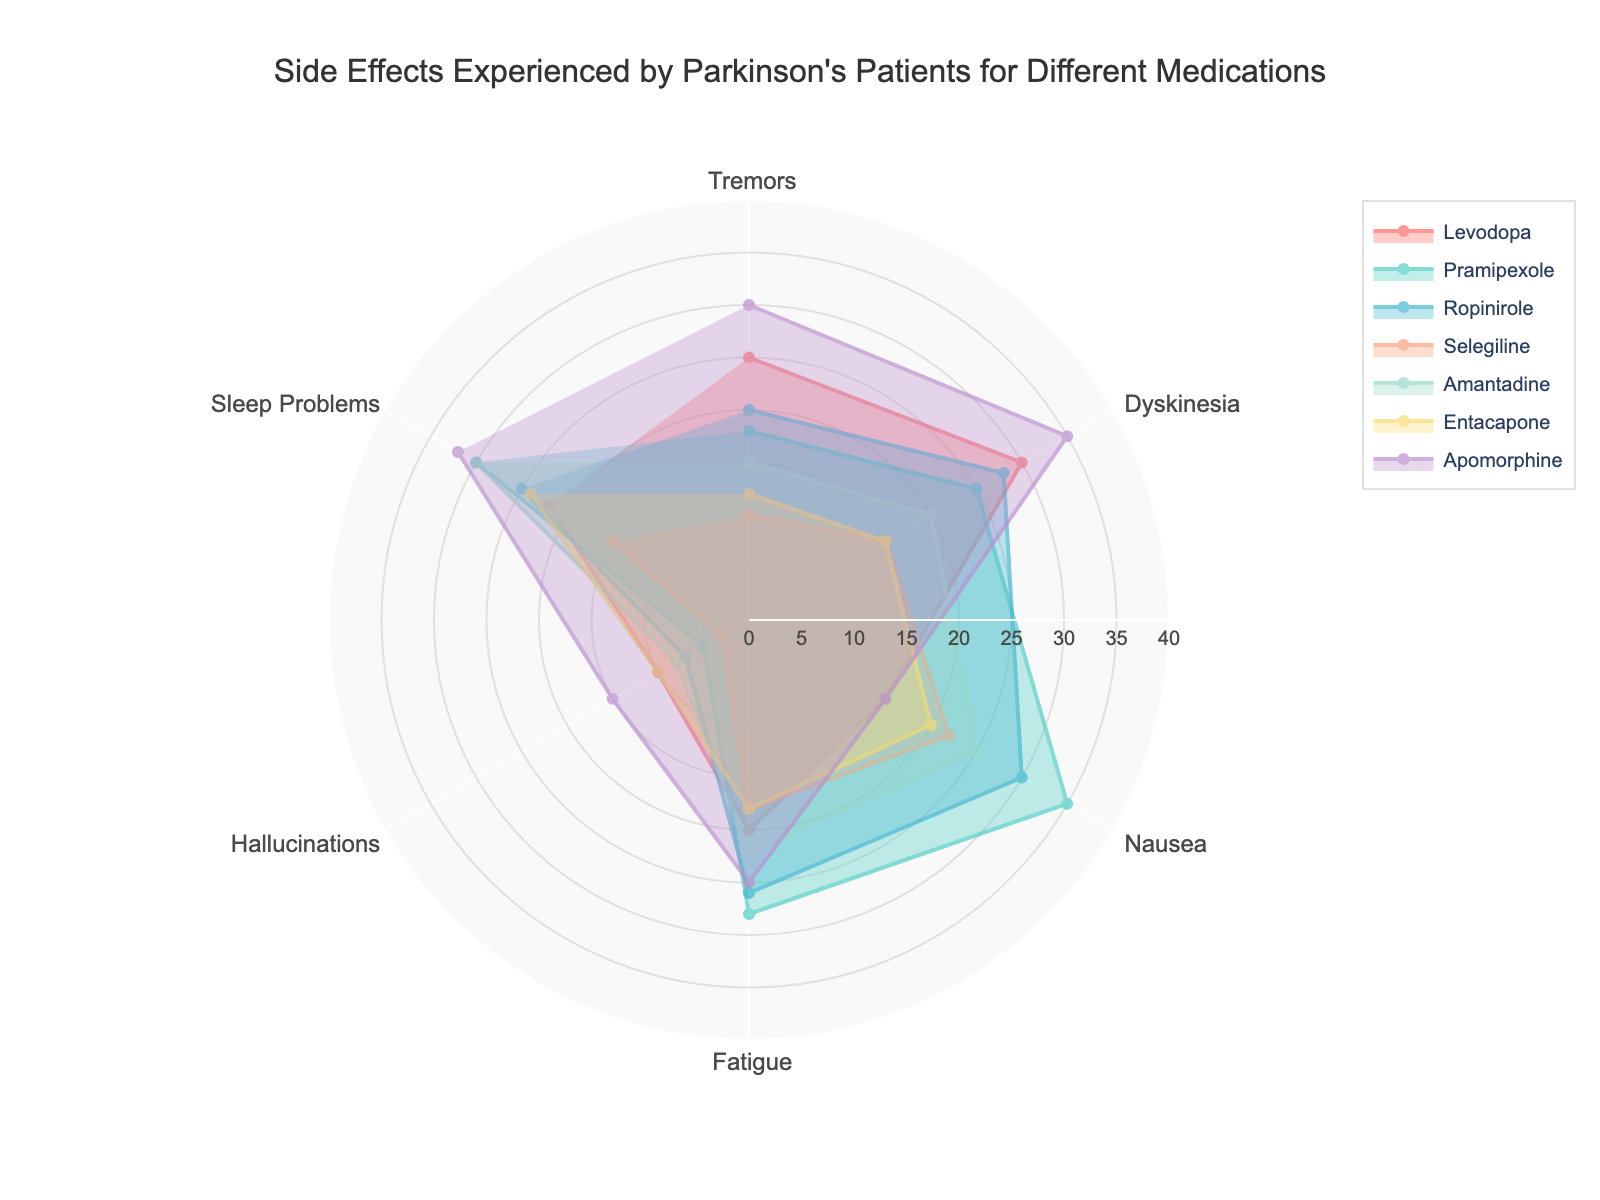What's the highest reported side effect for Levodopa? The radar chart shows the side effects with different radial lengths for Levodopa. The highest value for Levodopa corresponds to Dyskinesia, which has a radial length of 30 units.
Answer: Dyskinesia Which medication shows the highest levels of Fatigue? By looking at the radar chart, identify the radial length for Fatigue for each medication. Apomorphine has the highest radial length of 25 for Fatigue.
Answer: Apomorphine How does the experience of Tremors compare between Pramipexole and Apomorphine? Check the radial lengths for Tremors for both Pramipexole (18) and Apomorphine (30). Apomorphine shows a higher level of Tremors compared to Pramipexole.
Answer: Apomorphine shows higher levels Which medication results in the lowest level of Hallucinations? Look for the smallest radial length within the Hallucinations category. Selegiline has the smallest at 3 units.
Answer: Selegiline What are the similar side effects between Levodopa and Ropinirole? Compare the radar sections for Levodopa and Ropinirole. The data shows that Tremors and Dyskinesia have comparable radial lengths (25 vs 20 and 30 vs 28 respectively).
Answer: Tremors and Dyskinesia Which medication has the most balanced side effects across all categories? Look for the medication whose radial lengths for side effects are closest to each other. Entacapone has relatively similar lengths for all side effects, indicating a balanced profile.
Answer: Entacapone Which medication stands out with the highest Sleep Problems side effect? Identify the medication with the longest radial length for Sleep Problems. Apomorphine stands out with a radial length of 32 units.
Answer: Apomorphine What is the average level of Tremors experienced across all medications? Sum the Tremor values for all medications: 25 (Levodopa) + 18 (Pramipexole) + 20 (Ropinirole) + 10 (Selegiline) + 15 (Amantadine) + 12 (Entacapone) + 30 (Apomorphine) = 130. Then divide by the number of medications, which is 7. So, the average is 130/7 ≈ 18.57.
Answer: 18.57 Among all medications, which one has the highest total level of side effects? Sum the side effects for each medication and compare. Apomorphine has the highest total (30+35+15+25+15+32=152).
Answer: Apomorphine 